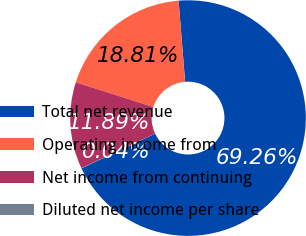Convert chart to OTSL. <chart><loc_0><loc_0><loc_500><loc_500><pie_chart><fcel>Total net revenue<fcel>Operating income from<fcel>Net income from continuing<fcel>Diluted net income per share<nl><fcel>69.25%<fcel>18.81%<fcel>11.89%<fcel>0.04%<nl></chart> 